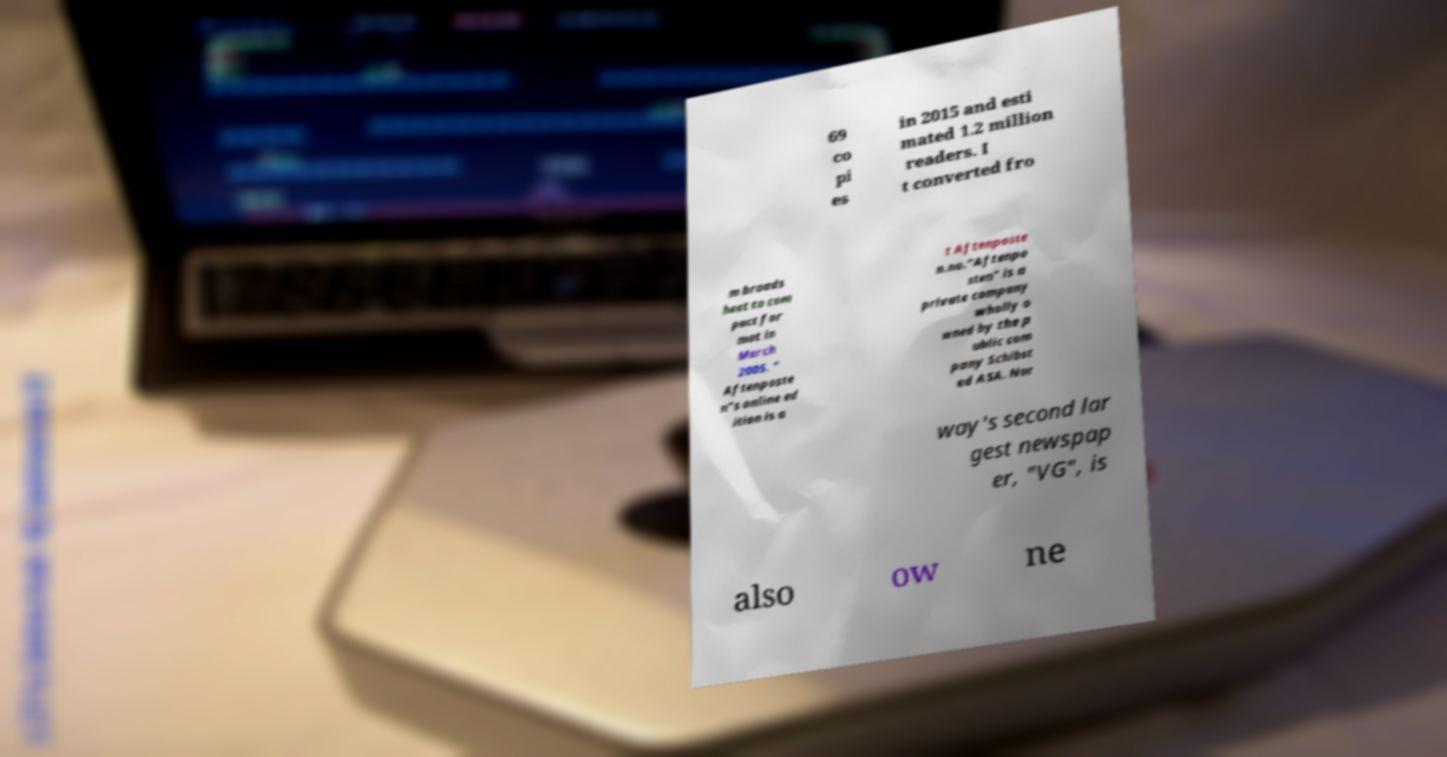For documentation purposes, I need the text within this image transcribed. Could you provide that? 69 co pi es in 2015 and esti mated 1.2 million readers. I t converted fro m broads heet to com pact for mat in March 2005. " Aftenposte n"s online ed ition is a t Aftenposte n.no."Aftenpo sten" is a private company wholly o wned by the p ublic com pany Schibst ed ASA. Nor way's second lar gest newspap er, "VG", is also ow ne 